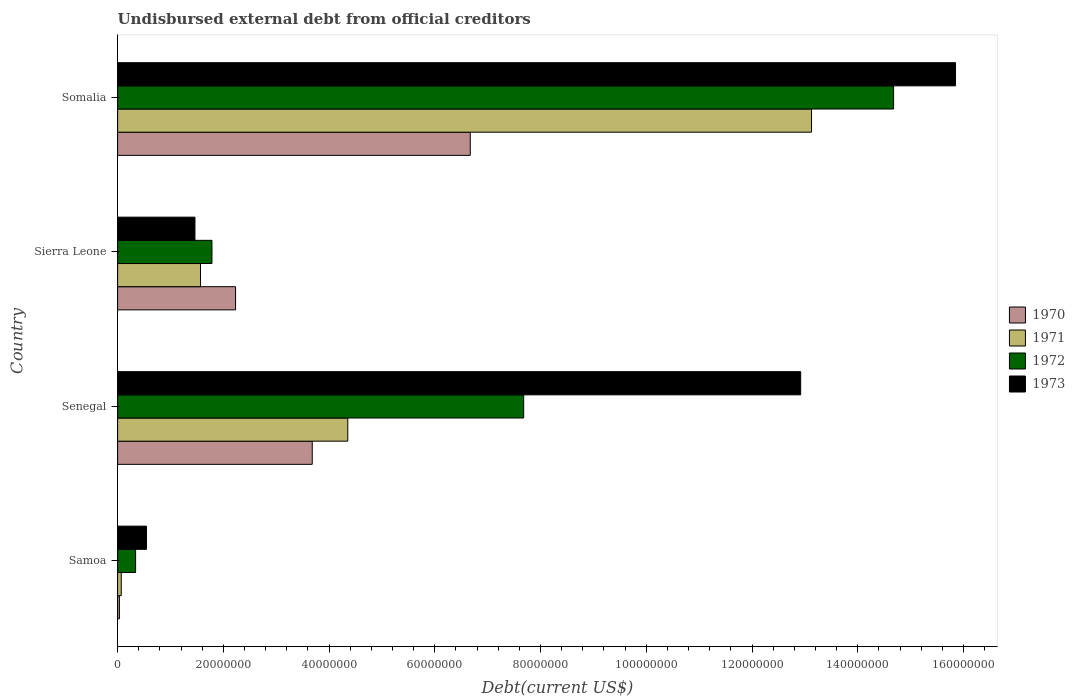How many groups of bars are there?
Your answer should be compact. 4. Are the number of bars per tick equal to the number of legend labels?
Offer a very short reply. Yes. How many bars are there on the 3rd tick from the bottom?
Ensure brevity in your answer.  4. What is the label of the 1st group of bars from the top?
Provide a short and direct response. Somalia. What is the total debt in 1971 in Senegal?
Provide a succinct answer. 4.35e+07. Across all countries, what is the maximum total debt in 1971?
Keep it short and to the point. 1.31e+08. Across all countries, what is the minimum total debt in 1973?
Keep it short and to the point. 5.46e+06. In which country was the total debt in 1971 maximum?
Your answer should be compact. Somalia. In which country was the total debt in 1972 minimum?
Give a very brief answer. Samoa. What is the total total debt in 1973 in the graph?
Offer a very short reply. 3.08e+08. What is the difference between the total debt in 1972 in Samoa and that in Senegal?
Keep it short and to the point. -7.34e+07. What is the difference between the total debt in 1970 in Sierra Leone and the total debt in 1973 in Senegal?
Provide a short and direct response. -1.07e+08. What is the average total debt in 1970 per country?
Your answer should be compact. 3.15e+07. What is the difference between the total debt in 1973 and total debt in 1972 in Somalia?
Give a very brief answer. 1.17e+07. What is the ratio of the total debt in 1971 in Senegal to that in Somalia?
Ensure brevity in your answer.  0.33. Is the total debt in 1972 in Samoa less than that in Senegal?
Provide a short and direct response. Yes. Is the difference between the total debt in 1973 in Samoa and Somalia greater than the difference between the total debt in 1972 in Samoa and Somalia?
Offer a very short reply. No. What is the difference between the highest and the second highest total debt in 1970?
Provide a succinct answer. 2.99e+07. What is the difference between the highest and the lowest total debt in 1970?
Keep it short and to the point. 6.64e+07. Is the sum of the total debt in 1972 in Samoa and Somalia greater than the maximum total debt in 1970 across all countries?
Your answer should be compact. Yes. Is it the case that in every country, the sum of the total debt in 1973 and total debt in 1972 is greater than the sum of total debt in 1971 and total debt in 1970?
Make the answer very short. No. What does the 2nd bar from the top in Sierra Leone represents?
Provide a short and direct response. 1972. Is it the case that in every country, the sum of the total debt in 1971 and total debt in 1973 is greater than the total debt in 1972?
Offer a very short reply. Yes. How many bars are there?
Offer a very short reply. 16. Are all the bars in the graph horizontal?
Your answer should be very brief. Yes. Are the values on the major ticks of X-axis written in scientific E-notation?
Your answer should be very brief. No. Does the graph contain grids?
Your response must be concise. No. Where does the legend appear in the graph?
Provide a succinct answer. Center right. How many legend labels are there?
Ensure brevity in your answer.  4. What is the title of the graph?
Offer a terse response. Undisbursed external debt from official creditors. What is the label or title of the X-axis?
Keep it short and to the point. Debt(current US$). What is the label or title of the Y-axis?
Make the answer very short. Country. What is the Debt(current US$) in 1970 in Samoa?
Offer a terse response. 3.36e+05. What is the Debt(current US$) of 1971 in Samoa?
Provide a succinct answer. 6.88e+05. What is the Debt(current US$) in 1972 in Samoa?
Give a very brief answer. 3.40e+06. What is the Debt(current US$) of 1973 in Samoa?
Provide a succinct answer. 5.46e+06. What is the Debt(current US$) of 1970 in Senegal?
Keep it short and to the point. 3.68e+07. What is the Debt(current US$) of 1971 in Senegal?
Your answer should be very brief. 4.35e+07. What is the Debt(current US$) of 1972 in Senegal?
Offer a very short reply. 7.68e+07. What is the Debt(current US$) of 1973 in Senegal?
Your answer should be compact. 1.29e+08. What is the Debt(current US$) of 1970 in Sierra Leone?
Give a very brief answer. 2.23e+07. What is the Debt(current US$) in 1971 in Sierra Leone?
Offer a very short reply. 1.57e+07. What is the Debt(current US$) of 1972 in Sierra Leone?
Your answer should be compact. 1.78e+07. What is the Debt(current US$) of 1973 in Sierra Leone?
Give a very brief answer. 1.46e+07. What is the Debt(current US$) of 1970 in Somalia?
Your answer should be compact. 6.67e+07. What is the Debt(current US$) in 1971 in Somalia?
Offer a terse response. 1.31e+08. What is the Debt(current US$) in 1972 in Somalia?
Your response must be concise. 1.47e+08. What is the Debt(current US$) of 1973 in Somalia?
Keep it short and to the point. 1.58e+08. Across all countries, what is the maximum Debt(current US$) in 1970?
Offer a very short reply. 6.67e+07. Across all countries, what is the maximum Debt(current US$) in 1971?
Give a very brief answer. 1.31e+08. Across all countries, what is the maximum Debt(current US$) of 1972?
Provide a succinct answer. 1.47e+08. Across all countries, what is the maximum Debt(current US$) of 1973?
Offer a terse response. 1.58e+08. Across all countries, what is the minimum Debt(current US$) in 1970?
Keep it short and to the point. 3.36e+05. Across all countries, what is the minimum Debt(current US$) in 1971?
Keep it short and to the point. 6.88e+05. Across all countries, what is the minimum Debt(current US$) of 1972?
Your answer should be very brief. 3.40e+06. Across all countries, what is the minimum Debt(current US$) in 1973?
Provide a short and direct response. 5.46e+06. What is the total Debt(current US$) of 1970 in the graph?
Your answer should be very brief. 1.26e+08. What is the total Debt(current US$) in 1971 in the graph?
Your response must be concise. 1.91e+08. What is the total Debt(current US$) in 1972 in the graph?
Offer a very short reply. 2.45e+08. What is the total Debt(current US$) in 1973 in the graph?
Provide a succinct answer. 3.08e+08. What is the difference between the Debt(current US$) in 1970 in Samoa and that in Senegal?
Your response must be concise. -3.65e+07. What is the difference between the Debt(current US$) in 1971 in Samoa and that in Senegal?
Your answer should be very brief. -4.29e+07. What is the difference between the Debt(current US$) in 1972 in Samoa and that in Senegal?
Keep it short and to the point. -7.34e+07. What is the difference between the Debt(current US$) of 1973 in Samoa and that in Senegal?
Your answer should be very brief. -1.24e+08. What is the difference between the Debt(current US$) of 1970 in Samoa and that in Sierra Leone?
Your answer should be compact. -2.20e+07. What is the difference between the Debt(current US$) of 1971 in Samoa and that in Sierra Leone?
Keep it short and to the point. -1.50e+07. What is the difference between the Debt(current US$) in 1972 in Samoa and that in Sierra Leone?
Keep it short and to the point. -1.44e+07. What is the difference between the Debt(current US$) of 1973 in Samoa and that in Sierra Leone?
Keep it short and to the point. -9.17e+06. What is the difference between the Debt(current US$) in 1970 in Samoa and that in Somalia?
Offer a very short reply. -6.64e+07. What is the difference between the Debt(current US$) of 1971 in Samoa and that in Somalia?
Provide a short and direct response. -1.31e+08. What is the difference between the Debt(current US$) of 1972 in Samoa and that in Somalia?
Provide a succinct answer. -1.43e+08. What is the difference between the Debt(current US$) in 1973 in Samoa and that in Somalia?
Offer a terse response. -1.53e+08. What is the difference between the Debt(current US$) of 1970 in Senegal and that in Sierra Leone?
Your answer should be compact. 1.45e+07. What is the difference between the Debt(current US$) of 1971 in Senegal and that in Sierra Leone?
Make the answer very short. 2.79e+07. What is the difference between the Debt(current US$) of 1972 in Senegal and that in Sierra Leone?
Your answer should be compact. 5.90e+07. What is the difference between the Debt(current US$) of 1973 in Senegal and that in Sierra Leone?
Keep it short and to the point. 1.15e+08. What is the difference between the Debt(current US$) of 1970 in Senegal and that in Somalia?
Offer a very short reply. -2.99e+07. What is the difference between the Debt(current US$) in 1971 in Senegal and that in Somalia?
Keep it short and to the point. -8.77e+07. What is the difference between the Debt(current US$) in 1972 in Senegal and that in Somalia?
Ensure brevity in your answer.  -7.00e+07. What is the difference between the Debt(current US$) in 1973 in Senegal and that in Somalia?
Your response must be concise. -2.93e+07. What is the difference between the Debt(current US$) of 1970 in Sierra Leone and that in Somalia?
Make the answer very short. -4.44e+07. What is the difference between the Debt(current US$) in 1971 in Sierra Leone and that in Somalia?
Your answer should be compact. -1.16e+08. What is the difference between the Debt(current US$) of 1972 in Sierra Leone and that in Somalia?
Ensure brevity in your answer.  -1.29e+08. What is the difference between the Debt(current US$) of 1973 in Sierra Leone and that in Somalia?
Provide a short and direct response. -1.44e+08. What is the difference between the Debt(current US$) in 1970 in Samoa and the Debt(current US$) in 1971 in Senegal?
Your answer should be very brief. -4.32e+07. What is the difference between the Debt(current US$) in 1970 in Samoa and the Debt(current US$) in 1972 in Senegal?
Your answer should be compact. -7.65e+07. What is the difference between the Debt(current US$) in 1970 in Samoa and the Debt(current US$) in 1973 in Senegal?
Give a very brief answer. -1.29e+08. What is the difference between the Debt(current US$) in 1971 in Samoa and the Debt(current US$) in 1972 in Senegal?
Your answer should be very brief. -7.61e+07. What is the difference between the Debt(current US$) in 1971 in Samoa and the Debt(current US$) in 1973 in Senegal?
Your response must be concise. -1.29e+08. What is the difference between the Debt(current US$) in 1972 in Samoa and the Debt(current US$) in 1973 in Senegal?
Your answer should be compact. -1.26e+08. What is the difference between the Debt(current US$) in 1970 in Samoa and the Debt(current US$) in 1971 in Sierra Leone?
Offer a terse response. -1.53e+07. What is the difference between the Debt(current US$) of 1970 in Samoa and the Debt(current US$) of 1972 in Sierra Leone?
Offer a terse response. -1.75e+07. What is the difference between the Debt(current US$) of 1970 in Samoa and the Debt(current US$) of 1973 in Sierra Leone?
Provide a short and direct response. -1.43e+07. What is the difference between the Debt(current US$) of 1971 in Samoa and the Debt(current US$) of 1972 in Sierra Leone?
Provide a short and direct response. -1.72e+07. What is the difference between the Debt(current US$) of 1971 in Samoa and the Debt(current US$) of 1973 in Sierra Leone?
Your answer should be very brief. -1.39e+07. What is the difference between the Debt(current US$) in 1972 in Samoa and the Debt(current US$) in 1973 in Sierra Leone?
Provide a succinct answer. -1.12e+07. What is the difference between the Debt(current US$) in 1970 in Samoa and the Debt(current US$) in 1971 in Somalia?
Provide a short and direct response. -1.31e+08. What is the difference between the Debt(current US$) in 1970 in Samoa and the Debt(current US$) in 1972 in Somalia?
Offer a terse response. -1.46e+08. What is the difference between the Debt(current US$) of 1970 in Samoa and the Debt(current US$) of 1973 in Somalia?
Your response must be concise. -1.58e+08. What is the difference between the Debt(current US$) of 1971 in Samoa and the Debt(current US$) of 1972 in Somalia?
Make the answer very short. -1.46e+08. What is the difference between the Debt(current US$) in 1971 in Samoa and the Debt(current US$) in 1973 in Somalia?
Provide a short and direct response. -1.58e+08. What is the difference between the Debt(current US$) of 1972 in Samoa and the Debt(current US$) of 1973 in Somalia?
Ensure brevity in your answer.  -1.55e+08. What is the difference between the Debt(current US$) of 1970 in Senegal and the Debt(current US$) of 1971 in Sierra Leone?
Make the answer very short. 2.11e+07. What is the difference between the Debt(current US$) in 1970 in Senegal and the Debt(current US$) in 1972 in Sierra Leone?
Offer a very short reply. 1.90e+07. What is the difference between the Debt(current US$) of 1970 in Senegal and the Debt(current US$) of 1973 in Sierra Leone?
Your response must be concise. 2.22e+07. What is the difference between the Debt(current US$) of 1971 in Senegal and the Debt(current US$) of 1972 in Sierra Leone?
Provide a succinct answer. 2.57e+07. What is the difference between the Debt(current US$) of 1971 in Senegal and the Debt(current US$) of 1973 in Sierra Leone?
Make the answer very short. 2.89e+07. What is the difference between the Debt(current US$) in 1972 in Senegal and the Debt(current US$) in 1973 in Sierra Leone?
Keep it short and to the point. 6.22e+07. What is the difference between the Debt(current US$) in 1970 in Senegal and the Debt(current US$) in 1971 in Somalia?
Make the answer very short. -9.44e+07. What is the difference between the Debt(current US$) in 1970 in Senegal and the Debt(current US$) in 1972 in Somalia?
Your answer should be compact. -1.10e+08. What is the difference between the Debt(current US$) in 1970 in Senegal and the Debt(current US$) in 1973 in Somalia?
Your answer should be very brief. -1.22e+08. What is the difference between the Debt(current US$) of 1971 in Senegal and the Debt(current US$) of 1972 in Somalia?
Provide a succinct answer. -1.03e+08. What is the difference between the Debt(current US$) in 1971 in Senegal and the Debt(current US$) in 1973 in Somalia?
Your answer should be compact. -1.15e+08. What is the difference between the Debt(current US$) of 1972 in Senegal and the Debt(current US$) of 1973 in Somalia?
Your answer should be compact. -8.17e+07. What is the difference between the Debt(current US$) of 1970 in Sierra Leone and the Debt(current US$) of 1971 in Somalia?
Keep it short and to the point. -1.09e+08. What is the difference between the Debt(current US$) in 1970 in Sierra Leone and the Debt(current US$) in 1972 in Somalia?
Provide a succinct answer. -1.24e+08. What is the difference between the Debt(current US$) of 1970 in Sierra Leone and the Debt(current US$) of 1973 in Somalia?
Make the answer very short. -1.36e+08. What is the difference between the Debt(current US$) in 1971 in Sierra Leone and the Debt(current US$) in 1972 in Somalia?
Ensure brevity in your answer.  -1.31e+08. What is the difference between the Debt(current US$) of 1971 in Sierra Leone and the Debt(current US$) of 1973 in Somalia?
Make the answer very short. -1.43e+08. What is the difference between the Debt(current US$) of 1972 in Sierra Leone and the Debt(current US$) of 1973 in Somalia?
Provide a succinct answer. -1.41e+08. What is the average Debt(current US$) of 1970 per country?
Your answer should be compact. 3.15e+07. What is the average Debt(current US$) of 1971 per country?
Your answer should be very brief. 4.78e+07. What is the average Debt(current US$) in 1972 per country?
Provide a succinct answer. 6.12e+07. What is the average Debt(current US$) in 1973 per country?
Provide a succinct answer. 7.69e+07. What is the difference between the Debt(current US$) of 1970 and Debt(current US$) of 1971 in Samoa?
Give a very brief answer. -3.52e+05. What is the difference between the Debt(current US$) of 1970 and Debt(current US$) of 1972 in Samoa?
Ensure brevity in your answer.  -3.07e+06. What is the difference between the Debt(current US$) of 1970 and Debt(current US$) of 1973 in Samoa?
Keep it short and to the point. -5.13e+06. What is the difference between the Debt(current US$) of 1971 and Debt(current US$) of 1972 in Samoa?
Your answer should be compact. -2.72e+06. What is the difference between the Debt(current US$) of 1971 and Debt(current US$) of 1973 in Samoa?
Offer a very short reply. -4.77e+06. What is the difference between the Debt(current US$) of 1972 and Debt(current US$) of 1973 in Samoa?
Make the answer very short. -2.06e+06. What is the difference between the Debt(current US$) of 1970 and Debt(current US$) of 1971 in Senegal?
Offer a terse response. -6.72e+06. What is the difference between the Debt(current US$) of 1970 and Debt(current US$) of 1972 in Senegal?
Keep it short and to the point. -4.00e+07. What is the difference between the Debt(current US$) of 1970 and Debt(current US$) of 1973 in Senegal?
Offer a very short reply. -9.24e+07. What is the difference between the Debt(current US$) in 1971 and Debt(current US$) in 1972 in Senegal?
Make the answer very short. -3.33e+07. What is the difference between the Debt(current US$) in 1971 and Debt(current US$) in 1973 in Senegal?
Your response must be concise. -8.57e+07. What is the difference between the Debt(current US$) in 1972 and Debt(current US$) in 1973 in Senegal?
Your answer should be very brief. -5.24e+07. What is the difference between the Debt(current US$) of 1970 and Debt(current US$) of 1971 in Sierra Leone?
Provide a short and direct response. 6.63e+06. What is the difference between the Debt(current US$) of 1970 and Debt(current US$) of 1972 in Sierra Leone?
Make the answer very short. 4.46e+06. What is the difference between the Debt(current US$) in 1970 and Debt(current US$) in 1973 in Sierra Leone?
Provide a succinct answer. 7.68e+06. What is the difference between the Debt(current US$) of 1971 and Debt(current US$) of 1972 in Sierra Leone?
Your response must be concise. -2.17e+06. What is the difference between the Debt(current US$) of 1971 and Debt(current US$) of 1973 in Sierra Leone?
Your answer should be very brief. 1.05e+06. What is the difference between the Debt(current US$) in 1972 and Debt(current US$) in 1973 in Sierra Leone?
Give a very brief answer. 3.22e+06. What is the difference between the Debt(current US$) of 1970 and Debt(current US$) of 1971 in Somalia?
Your answer should be very brief. -6.45e+07. What is the difference between the Debt(current US$) of 1970 and Debt(current US$) of 1972 in Somalia?
Your answer should be very brief. -8.01e+07. What is the difference between the Debt(current US$) of 1970 and Debt(current US$) of 1973 in Somalia?
Offer a very short reply. -9.18e+07. What is the difference between the Debt(current US$) in 1971 and Debt(current US$) in 1972 in Somalia?
Keep it short and to the point. -1.55e+07. What is the difference between the Debt(current US$) of 1971 and Debt(current US$) of 1973 in Somalia?
Your answer should be compact. -2.72e+07. What is the difference between the Debt(current US$) of 1972 and Debt(current US$) of 1973 in Somalia?
Your answer should be compact. -1.17e+07. What is the ratio of the Debt(current US$) in 1970 in Samoa to that in Senegal?
Keep it short and to the point. 0.01. What is the ratio of the Debt(current US$) of 1971 in Samoa to that in Senegal?
Ensure brevity in your answer.  0.02. What is the ratio of the Debt(current US$) of 1972 in Samoa to that in Senegal?
Your answer should be compact. 0.04. What is the ratio of the Debt(current US$) in 1973 in Samoa to that in Senegal?
Keep it short and to the point. 0.04. What is the ratio of the Debt(current US$) in 1970 in Samoa to that in Sierra Leone?
Your answer should be compact. 0.02. What is the ratio of the Debt(current US$) of 1971 in Samoa to that in Sierra Leone?
Ensure brevity in your answer.  0.04. What is the ratio of the Debt(current US$) in 1972 in Samoa to that in Sierra Leone?
Your answer should be very brief. 0.19. What is the ratio of the Debt(current US$) of 1973 in Samoa to that in Sierra Leone?
Provide a succinct answer. 0.37. What is the ratio of the Debt(current US$) in 1970 in Samoa to that in Somalia?
Provide a succinct answer. 0.01. What is the ratio of the Debt(current US$) in 1971 in Samoa to that in Somalia?
Your response must be concise. 0.01. What is the ratio of the Debt(current US$) in 1972 in Samoa to that in Somalia?
Make the answer very short. 0.02. What is the ratio of the Debt(current US$) of 1973 in Samoa to that in Somalia?
Give a very brief answer. 0.03. What is the ratio of the Debt(current US$) in 1970 in Senegal to that in Sierra Leone?
Your answer should be very brief. 1.65. What is the ratio of the Debt(current US$) in 1971 in Senegal to that in Sierra Leone?
Provide a succinct answer. 2.78. What is the ratio of the Debt(current US$) of 1972 in Senegal to that in Sierra Leone?
Give a very brief answer. 4.3. What is the ratio of the Debt(current US$) in 1973 in Senegal to that in Sierra Leone?
Keep it short and to the point. 8.83. What is the ratio of the Debt(current US$) of 1970 in Senegal to that in Somalia?
Your answer should be compact. 0.55. What is the ratio of the Debt(current US$) of 1971 in Senegal to that in Somalia?
Your answer should be compact. 0.33. What is the ratio of the Debt(current US$) of 1972 in Senegal to that in Somalia?
Your answer should be very brief. 0.52. What is the ratio of the Debt(current US$) in 1973 in Senegal to that in Somalia?
Provide a succinct answer. 0.82. What is the ratio of the Debt(current US$) in 1970 in Sierra Leone to that in Somalia?
Your answer should be compact. 0.33. What is the ratio of the Debt(current US$) in 1971 in Sierra Leone to that in Somalia?
Provide a short and direct response. 0.12. What is the ratio of the Debt(current US$) in 1972 in Sierra Leone to that in Somalia?
Offer a terse response. 0.12. What is the ratio of the Debt(current US$) in 1973 in Sierra Leone to that in Somalia?
Your response must be concise. 0.09. What is the difference between the highest and the second highest Debt(current US$) of 1970?
Your response must be concise. 2.99e+07. What is the difference between the highest and the second highest Debt(current US$) in 1971?
Keep it short and to the point. 8.77e+07. What is the difference between the highest and the second highest Debt(current US$) of 1972?
Your response must be concise. 7.00e+07. What is the difference between the highest and the second highest Debt(current US$) of 1973?
Your answer should be compact. 2.93e+07. What is the difference between the highest and the lowest Debt(current US$) of 1970?
Your answer should be compact. 6.64e+07. What is the difference between the highest and the lowest Debt(current US$) of 1971?
Make the answer very short. 1.31e+08. What is the difference between the highest and the lowest Debt(current US$) of 1972?
Your answer should be compact. 1.43e+08. What is the difference between the highest and the lowest Debt(current US$) of 1973?
Provide a succinct answer. 1.53e+08. 